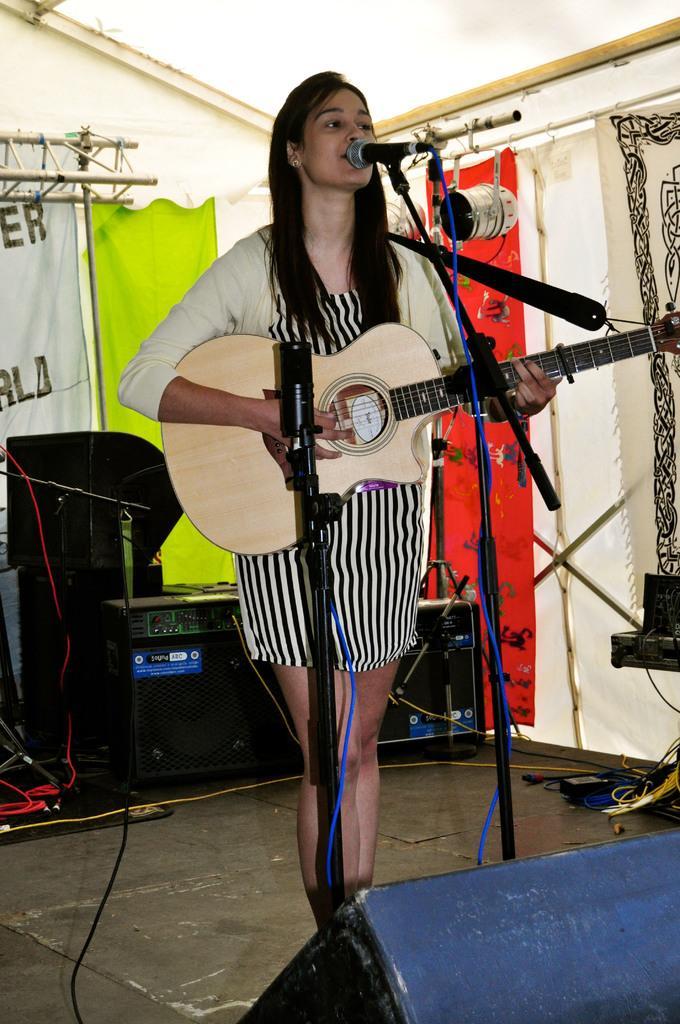Can you describe this image briefly? In this image we can see a woman is standing and singing, and playing the guitar, and at back there are some objects, and here is the curtain. 